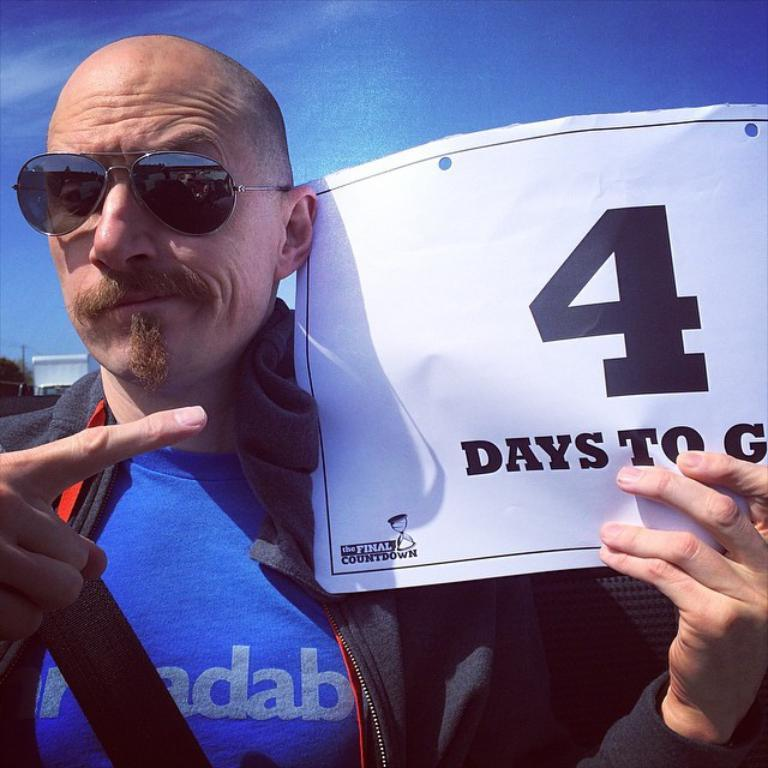Who is present in the image? There is a man in the image. What is the man wearing on his face? The man is wearing spectacles. What is the man holding in his hand? The man is holding a paper in his hand. What can be seen in the background of the image? There is a pole, trees, and clouds in the background of the image. What type of coat is the girl wearing in the image? There is no girl present in the image, so it is not possible to answer that question. 